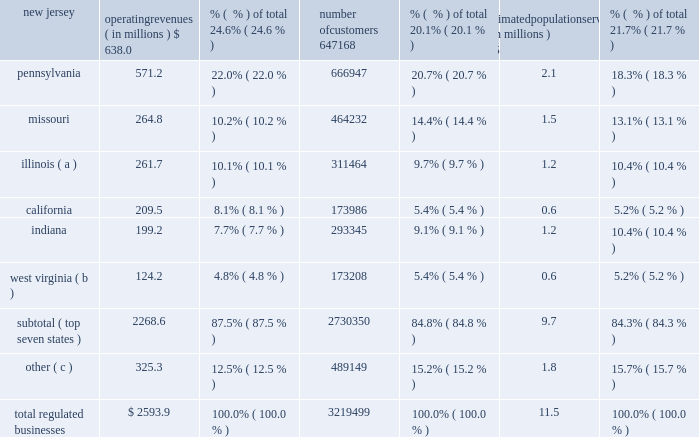Acquisition added approximately 1700 water customers and nearly 2000 wastewater customers .
The tex as assets served approximately 4200 water and 1100 wastewater customers in the greater houston metropolitan as noted above , as a result of these sales , these regulated subsidiaries are presented as discontinued operations for all periods presented .
Therefore , the amounts , statistics and tables presented in this section refer only to on-going operations , unless otherwise noted .
The table sets forth our regulated businesses operating revenue for 2013 and number of customers from continuing operations as well as an estimate of population served as of december 31 , 2013 : operating revenues ( in millions ) % (  % ) of total number of customers % (  % ) of total estimated population served ( in millions ) % (  % ) of total .
( a ) includes illinois-american water company , which we refer to as ilawc and american lake water company , also a regulated subsidiary in illinois .
( b ) west virginia-american water company , which we refer to as wvawc , and its subsidiary bluefield valley water works company .
( c ) includes data from our operating subsidiaries in the following states : georgia , hawaii , iowa , kentucky , maryland , michigan , new york , tennessee , and virginia .
Approximately 87.5 % (  % ) of operating revenue from our regulated businesses in 2013 was generated from approximately 2.7 million customers in our seven largest states , as measured by operating revenues .
In fiscal year 2013 , no single customer accounted for more than 10% ( 10 % ) of our annual operating revenue .
Overview of networks , facilities and water supply our regulated businesses operate in approximately 1500 communities in 16 states in the united states .
Our primary operating assets include 87 dams along with approximately 80 surface water treatment plants , 500 groundwater treatment plants , 1000 groundwater wells , 100 wastewater treatment facilities , 1200 treated water storage facilities , 1300 pumping stations , and 47000 miles of mains and collection pipes .
Our regulated utilities own substantially all of the assets used by our regulated businesses .
We generally own the land and physical assets used to store , extract and treat source water .
Typically , we do not own the water itself , which is held in public trust and is allocated to us through contracts and allocation rights granted by federal and state agencies or through the ownership of water rights pursuant to local law .
Maintaining the reliability of our networks is a key activity of our regulated businesses .
We have ongoing infrastructure renewal programs in all states in which our regulated businesses operate .
These programs consist of both rehabilitation of existing mains and replacement of mains that have reached the end of their useful service lives .
Our ability to meet the existing and future water demands of our customers depends on an adequate supply of water .
Drought , governmental restrictions , overuse of sources of water , the protection of threatened species or .
What is the average annual revenue per customer in new jersey? 
Computations: ((638.0 * 1000000) / 647168)
Answer: 985.83366. 